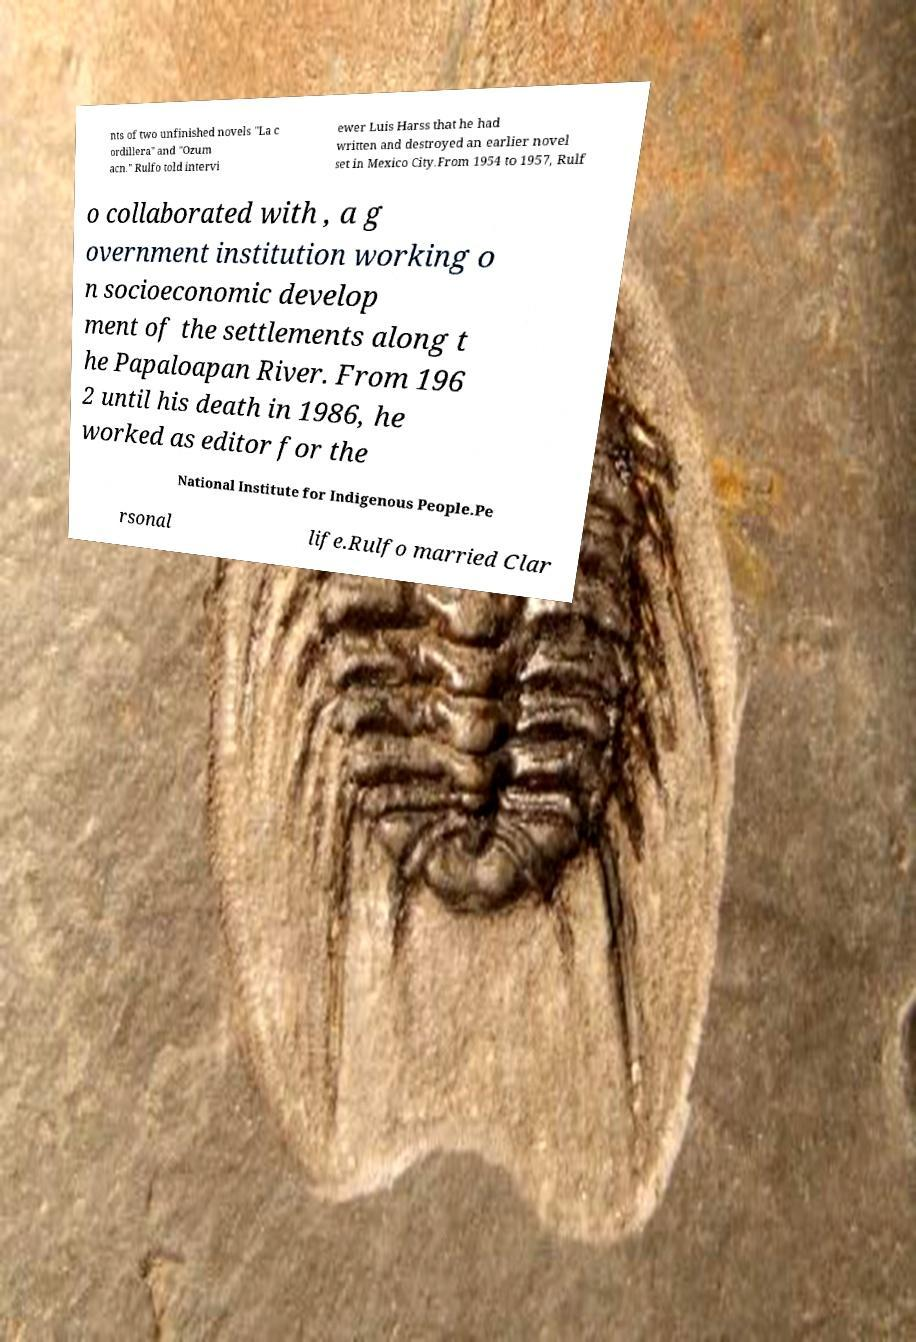Can you read and provide the text displayed in the image?This photo seems to have some interesting text. Can you extract and type it out for me? nts of two unfinished novels "La c ordillera" and "Ozum acn." Rulfo told intervi ewer Luis Harss that he had written and destroyed an earlier novel set in Mexico City.From 1954 to 1957, Rulf o collaborated with , a g overnment institution working o n socioeconomic develop ment of the settlements along t he Papaloapan River. From 196 2 until his death in 1986, he worked as editor for the National Institute for Indigenous People.Pe rsonal life.Rulfo married Clar 